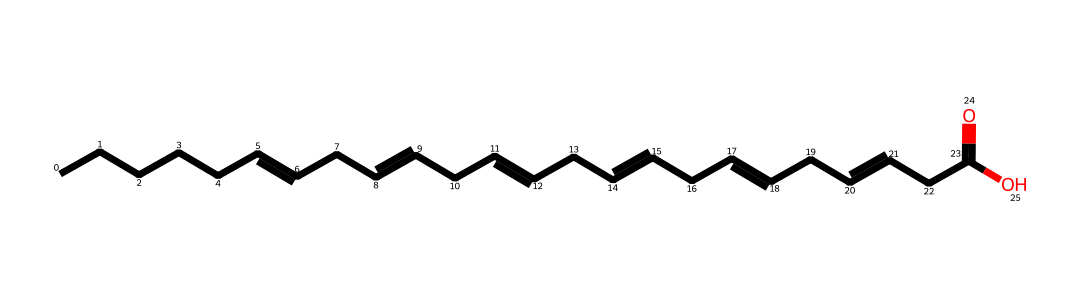How many carbon atoms are in this omega-3 fatty acid? The SMILES representation indicates the presence of multiple carbon atoms, specifically counting the number of 'C' characters, which denote carbon. In the structure provided, there are 20 carbon atoms total.
Answer: 20 What functional group is present in this chemical structure? The presence of the 'C(=O)O' part of the SMILES shows that this structure contains a carboxylic acid functional group, indicated by the -COOH.
Answer: carboxylic acid Is this fatty acid saturated or unsaturated? The presence of double bonds ('=') in the SMILES representation indicates that it is unsaturated. There are multiple places where double bonds appear, confirming its unsaturated nature.
Answer: unsaturated What is the role of this fatty acid in the body? Omega-3 fatty acids, particularly EPA and DHA, are known to play a role in reducing inflammation and are essential for various bodily functions such as heart and brain health.
Answer: reduces inflammation How many double bonds does this fatty acid have? By examining the SMILES representation, we can identify the locations of the double bonds denoted by '=', totaling four double bonds in the structure.
Answer: 4 What type of chemical is this omega-3 fatty acid classified as? Given that this compound is a long-chain fatty acid with multiple unsaturated bonds, it is classified as a polyunsaturated fatty acid (PUFA).
Answer: polyunsaturated fatty acid 